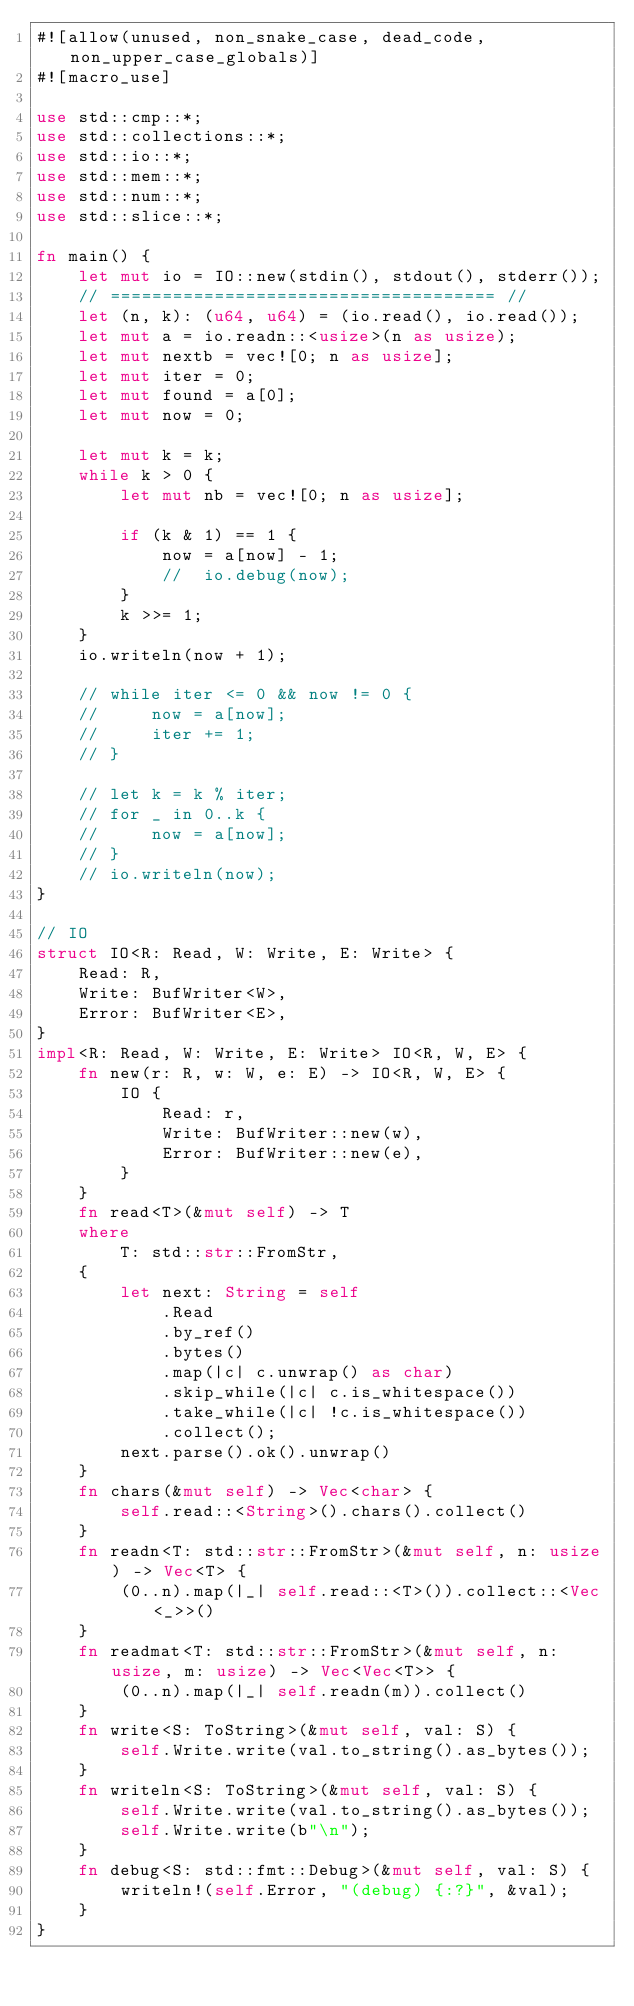<code> <loc_0><loc_0><loc_500><loc_500><_Rust_>#![allow(unused, non_snake_case, dead_code, non_upper_case_globals)]
#![macro_use]

use std::cmp::*;
use std::collections::*;
use std::io::*;
use std::mem::*;
use std::num::*;
use std::slice::*;

fn main() {
    let mut io = IO::new(stdin(), stdout(), stderr());
    // ===================================== //
    let (n, k): (u64, u64) = (io.read(), io.read());
    let mut a = io.readn::<usize>(n as usize);
    let mut nextb = vec![0; n as usize];
    let mut iter = 0;
    let mut found = a[0];
    let mut now = 0;

    let mut k = k;
    while k > 0 {
        let mut nb = vec![0; n as usize];

        if (k & 1) == 1 {
            now = a[now] - 1;
            //  io.debug(now);
        }
        k >>= 1;
    }
    io.writeln(now + 1);

    // while iter <= 0 && now != 0 {
    //     now = a[now];
    //     iter += 1;
    // }

    // let k = k % iter;
    // for _ in 0..k {
    //     now = a[now];
    // }
    // io.writeln(now);
}

// IO
struct IO<R: Read, W: Write, E: Write> {
    Read: R,
    Write: BufWriter<W>,
    Error: BufWriter<E>,
}
impl<R: Read, W: Write, E: Write> IO<R, W, E> {
    fn new(r: R, w: W, e: E) -> IO<R, W, E> {
        IO {
            Read: r,
            Write: BufWriter::new(w),
            Error: BufWriter::new(e),
        }
    }
    fn read<T>(&mut self) -> T
    where
        T: std::str::FromStr,
    {
        let next: String = self
            .Read
            .by_ref()
            .bytes()
            .map(|c| c.unwrap() as char)
            .skip_while(|c| c.is_whitespace())
            .take_while(|c| !c.is_whitespace())
            .collect();
        next.parse().ok().unwrap()
    }
    fn chars(&mut self) -> Vec<char> {
        self.read::<String>().chars().collect()
    }
    fn readn<T: std::str::FromStr>(&mut self, n: usize) -> Vec<T> {
        (0..n).map(|_| self.read::<T>()).collect::<Vec<_>>()
    }
    fn readmat<T: std::str::FromStr>(&mut self, n: usize, m: usize) -> Vec<Vec<T>> {
        (0..n).map(|_| self.readn(m)).collect()
    }
    fn write<S: ToString>(&mut self, val: S) {
        self.Write.write(val.to_string().as_bytes());
    }
    fn writeln<S: ToString>(&mut self, val: S) {
        self.Write.write(val.to_string().as_bytes());
        self.Write.write(b"\n");
    }
    fn debug<S: std::fmt::Debug>(&mut self, val: S) {
        writeln!(self.Error, "(debug) {:?}", &val);
    }
}
</code> 